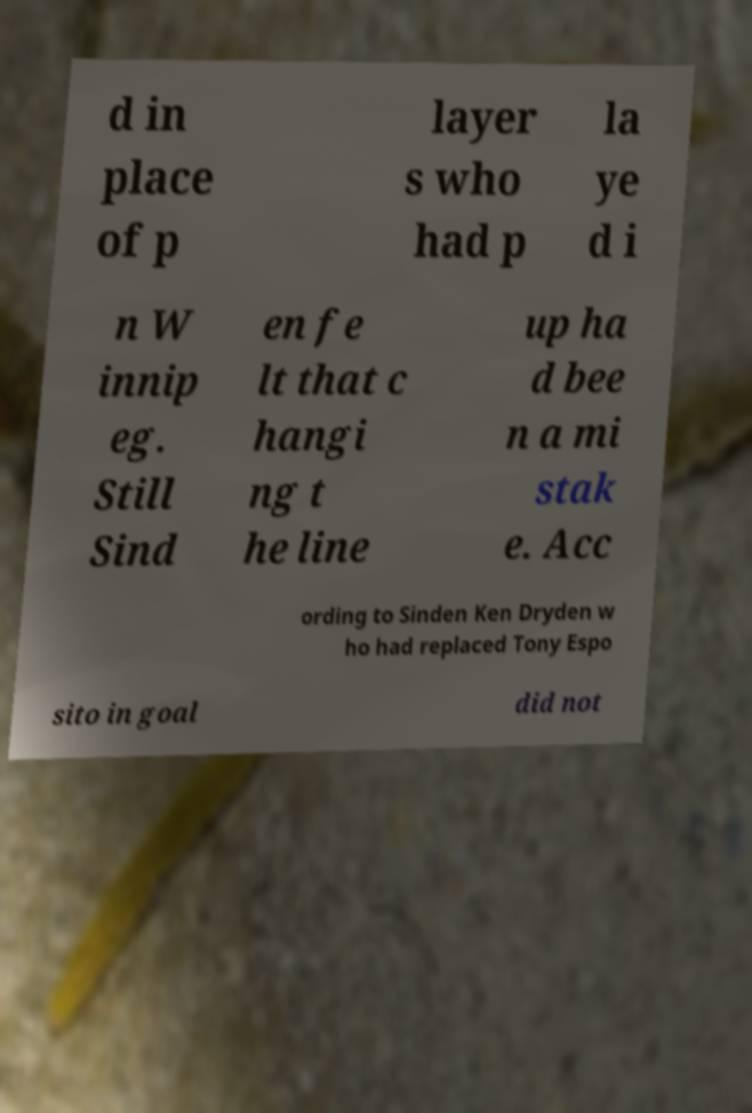Can you accurately transcribe the text from the provided image for me? d in place of p layer s who had p la ye d i n W innip eg. Still Sind en fe lt that c hangi ng t he line up ha d bee n a mi stak e. Acc ording to Sinden Ken Dryden w ho had replaced Tony Espo sito in goal did not 